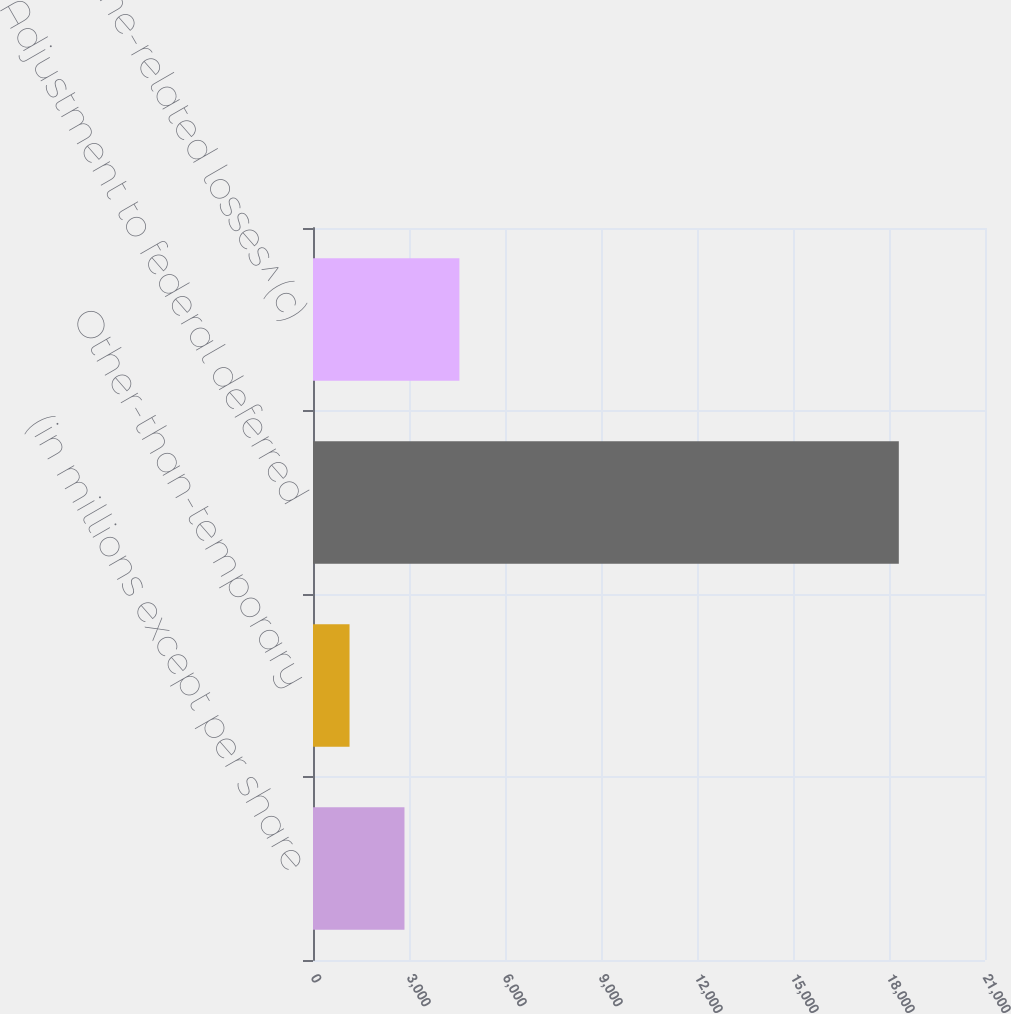<chart> <loc_0><loc_0><loc_500><loc_500><bar_chart><fcel>(in millions except per share<fcel>Other-than-temporary<fcel>Adjustment to federal deferred<fcel>Catastrophe-related losses^(c)<nl><fcel>2858.5<fcel>1142<fcel>18307<fcel>4575<nl></chart> 